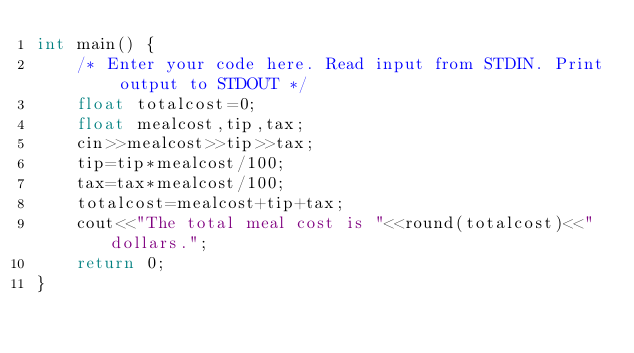Convert code to text. <code><loc_0><loc_0><loc_500><loc_500><_C++_>int main() {
    /* Enter your code here. Read input from STDIN. Print output to STDOUT */
    float totalcost=0;
    float mealcost,tip,tax;
    cin>>mealcost>>tip>>tax;
    tip=tip*mealcost/100;
    tax=tax*mealcost/100;
    totalcost=mealcost+tip+tax;
    cout<<"The total meal cost is "<<round(totalcost)<<" dollars.";
    return 0;
}
</code> 